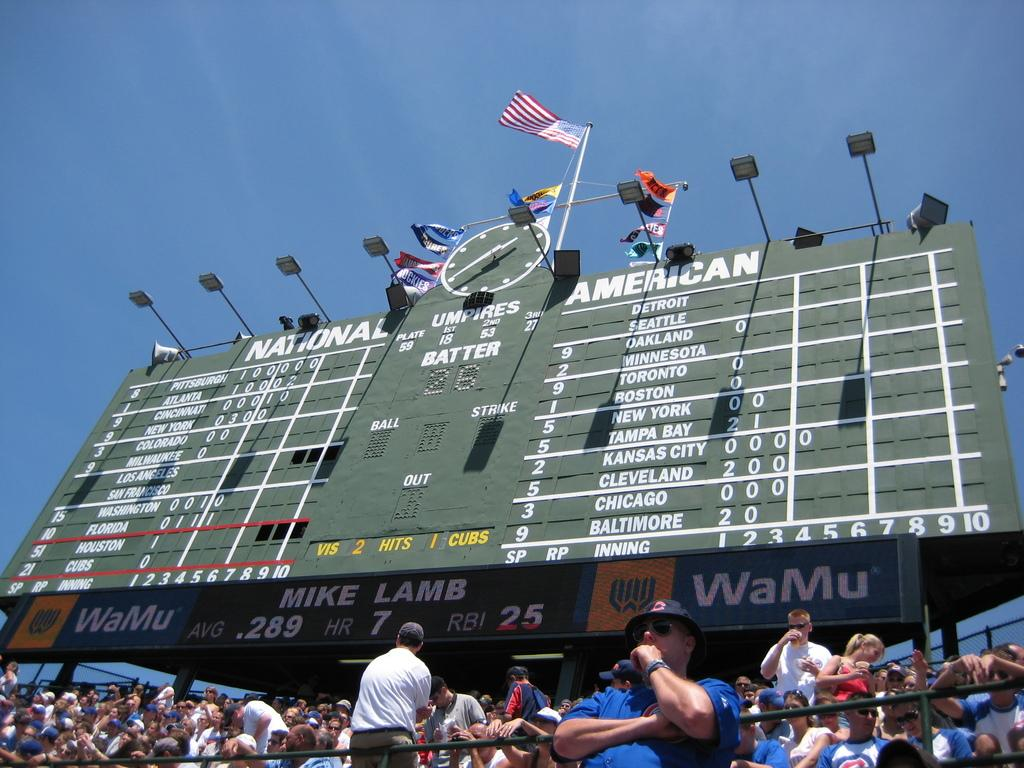Provide a one-sentence caption for the provided image. The WaMu sponsored scoreboard shows the statistics for player Mike Lamb. 